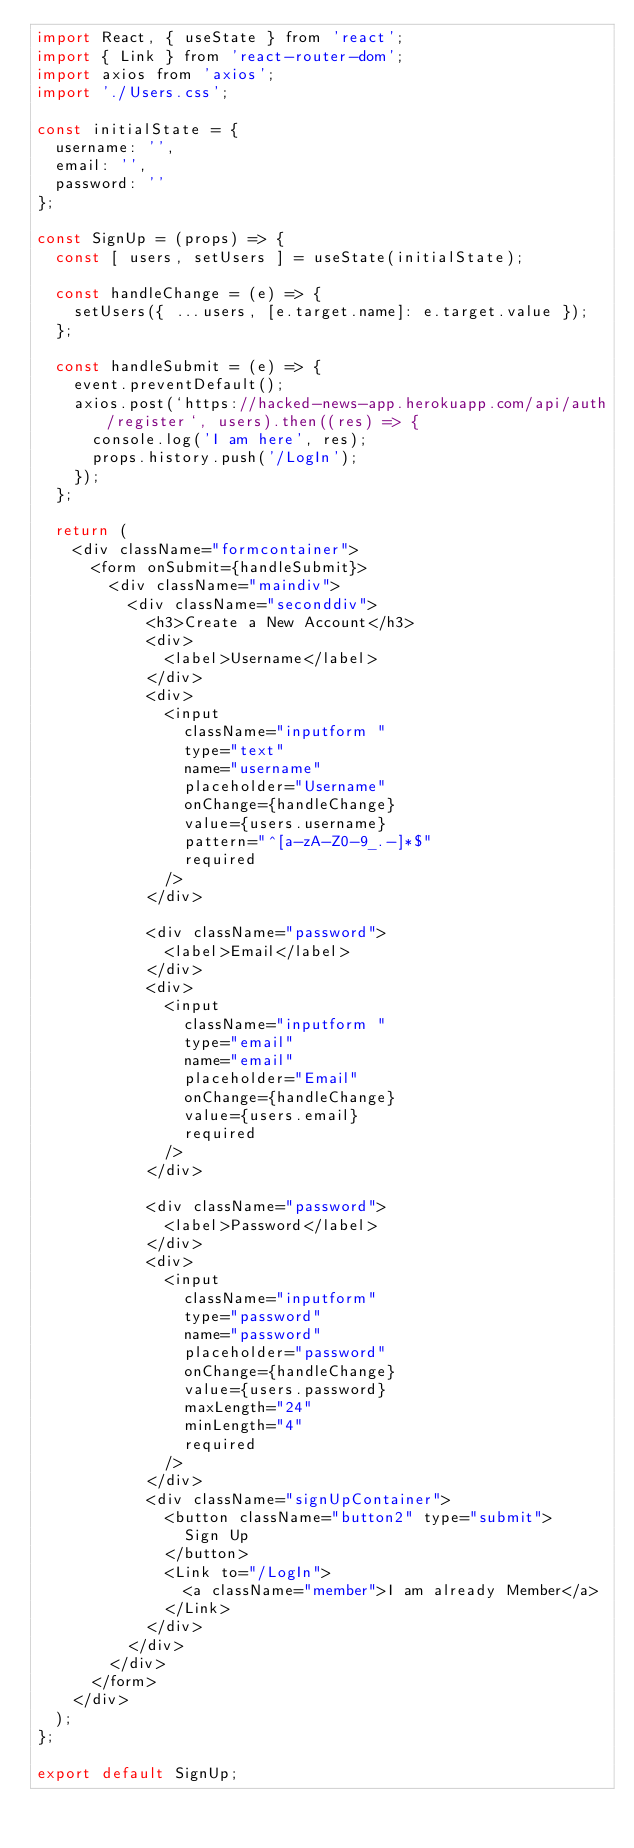<code> <loc_0><loc_0><loc_500><loc_500><_JavaScript_>import React, { useState } from 'react';
import { Link } from 'react-router-dom';
import axios from 'axios';
import './Users.css';

const initialState = {
	username: '',
	email: '',
	password: ''
};

const SignUp = (props) => {
	const [ users, setUsers ] = useState(initialState);

	const handleChange = (e) => {
		setUsers({ ...users, [e.target.name]: e.target.value });
	};

	const handleSubmit = (e) => {
		event.preventDefault();
		axios.post(`https://hacked-news-app.herokuapp.com/api/auth/register`, users).then((res) => {
			console.log('I am here', res);
			props.history.push('/LogIn');
		});
	};

	return (
		<div className="formcontainer">
			<form onSubmit={handleSubmit}>
				<div className="maindiv">
					<div className="seconddiv">
						<h3>Create a New Account</h3>
						<div>
							<label>Username</label>
						</div>
						<div>
							<input
								className="inputform "
								type="text"
								name="username"
								placeholder="Username"
								onChange={handleChange}
								value={users.username}
								pattern="^[a-zA-Z0-9_.-]*$"
								required
							/>
						</div>

						<div className="password">
							<label>Email</label>
						</div>
						<div>
							<input
								className="inputform "
								type="email"
								name="email"
								placeholder="Email"
								onChange={handleChange}
								value={users.email}
								required
							/>
						</div>

						<div className="password">
							<label>Password</label>
						</div>
						<div>
							<input
								className="inputform"
								type="password"
								name="password"
								placeholder="password"
								onChange={handleChange}
								value={users.password}
								maxLength="24"
								minLength="4"
								required
							/>
						</div>
						<div className="signUpContainer">
							<button className="button2" type="submit">
								Sign Up
							</button>
							<Link to="/LogIn">
								<a className="member">I am already Member</a>
							</Link>
						</div>
					</div>
				</div>
			</form>
		</div>
	);
};

export default SignUp;
</code> 